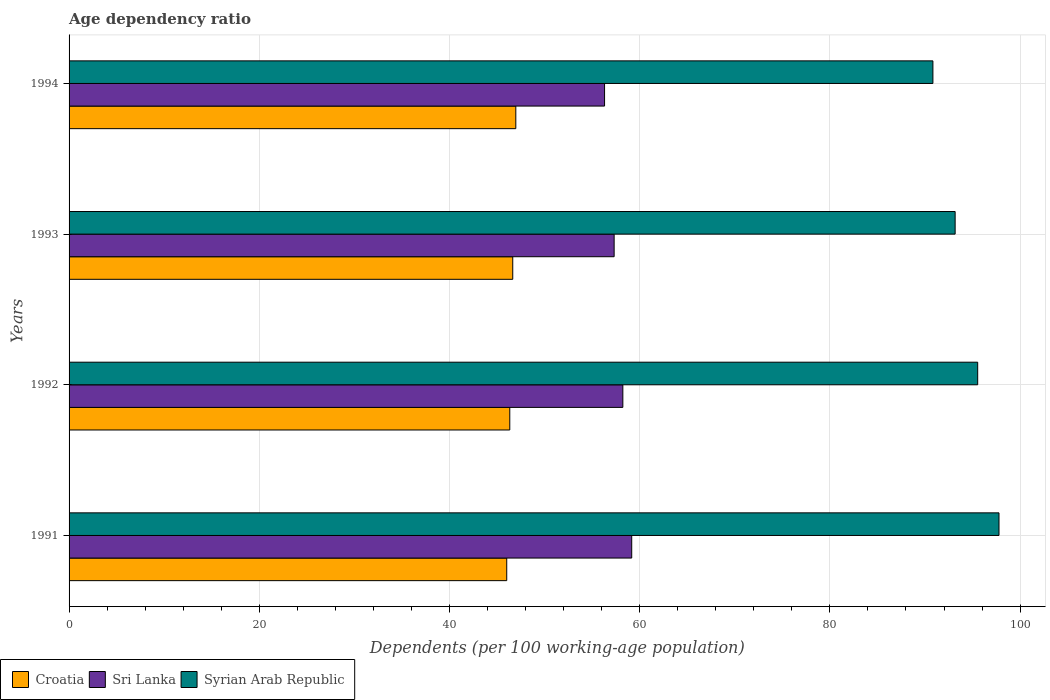How many different coloured bars are there?
Provide a short and direct response. 3. Are the number of bars per tick equal to the number of legend labels?
Provide a short and direct response. Yes. How many bars are there on the 3rd tick from the top?
Provide a short and direct response. 3. How many bars are there on the 4th tick from the bottom?
Ensure brevity in your answer.  3. In how many cases, is the number of bars for a given year not equal to the number of legend labels?
Offer a very short reply. 0. What is the age dependency ratio in in Sri Lanka in 1994?
Your answer should be very brief. 56.31. Across all years, what is the maximum age dependency ratio in in Syrian Arab Republic?
Your response must be concise. 97.78. Across all years, what is the minimum age dependency ratio in in Syrian Arab Republic?
Offer a terse response. 90.83. In which year was the age dependency ratio in in Syrian Arab Republic maximum?
Your answer should be compact. 1991. In which year was the age dependency ratio in in Croatia minimum?
Offer a very short reply. 1991. What is the total age dependency ratio in in Sri Lanka in the graph?
Ensure brevity in your answer.  231.01. What is the difference between the age dependency ratio in in Croatia in 1991 and that in 1993?
Your response must be concise. -0.63. What is the difference between the age dependency ratio in in Sri Lanka in 1993 and the age dependency ratio in in Croatia in 1992?
Keep it short and to the point. 10.97. What is the average age dependency ratio in in Sri Lanka per year?
Offer a very short reply. 57.75. In the year 1991, what is the difference between the age dependency ratio in in Croatia and age dependency ratio in in Sri Lanka?
Provide a short and direct response. -13.14. What is the ratio of the age dependency ratio in in Sri Lanka in 1991 to that in 1994?
Make the answer very short. 1.05. Is the difference between the age dependency ratio in in Croatia in 1991 and 1994 greater than the difference between the age dependency ratio in in Sri Lanka in 1991 and 1994?
Offer a very short reply. No. What is the difference between the highest and the second highest age dependency ratio in in Croatia?
Provide a succinct answer. 0.32. What is the difference between the highest and the lowest age dependency ratio in in Croatia?
Make the answer very short. 0.95. What does the 3rd bar from the top in 1992 represents?
Provide a succinct answer. Croatia. What does the 2nd bar from the bottom in 1992 represents?
Make the answer very short. Sri Lanka. Is it the case that in every year, the sum of the age dependency ratio in in Sri Lanka and age dependency ratio in in Syrian Arab Republic is greater than the age dependency ratio in in Croatia?
Make the answer very short. Yes. Are all the bars in the graph horizontal?
Offer a very short reply. Yes. How many years are there in the graph?
Your response must be concise. 4. What is the difference between two consecutive major ticks on the X-axis?
Make the answer very short. 20. Are the values on the major ticks of X-axis written in scientific E-notation?
Provide a succinct answer. No. Does the graph contain grids?
Your response must be concise. Yes. Where does the legend appear in the graph?
Your answer should be compact. Bottom left. What is the title of the graph?
Keep it short and to the point. Age dependency ratio. Does "Gambia, The" appear as one of the legend labels in the graph?
Make the answer very short. No. What is the label or title of the X-axis?
Offer a very short reply. Dependents (per 100 working-age population). What is the label or title of the Y-axis?
Provide a short and direct response. Years. What is the Dependents (per 100 working-age population) of Croatia in 1991?
Your response must be concise. 46.02. What is the Dependents (per 100 working-age population) in Sri Lanka in 1991?
Provide a short and direct response. 59.16. What is the Dependents (per 100 working-age population) of Syrian Arab Republic in 1991?
Your response must be concise. 97.78. What is the Dependents (per 100 working-age population) in Croatia in 1992?
Give a very brief answer. 46.34. What is the Dependents (per 100 working-age population) in Sri Lanka in 1992?
Your answer should be very brief. 58.23. What is the Dependents (per 100 working-age population) of Syrian Arab Republic in 1992?
Make the answer very short. 95.54. What is the Dependents (per 100 working-age population) of Croatia in 1993?
Your response must be concise. 46.65. What is the Dependents (per 100 working-age population) of Sri Lanka in 1993?
Ensure brevity in your answer.  57.31. What is the Dependents (per 100 working-age population) in Syrian Arab Republic in 1993?
Your answer should be compact. 93.17. What is the Dependents (per 100 working-age population) in Croatia in 1994?
Give a very brief answer. 46.97. What is the Dependents (per 100 working-age population) of Sri Lanka in 1994?
Keep it short and to the point. 56.31. What is the Dependents (per 100 working-age population) in Syrian Arab Republic in 1994?
Offer a terse response. 90.83. Across all years, what is the maximum Dependents (per 100 working-age population) in Croatia?
Provide a short and direct response. 46.97. Across all years, what is the maximum Dependents (per 100 working-age population) of Sri Lanka?
Provide a short and direct response. 59.16. Across all years, what is the maximum Dependents (per 100 working-age population) of Syrian Arab Republic?
Make the answer very short. 97.78. Across all years, what is the minimum Dependents (per 100 working-age population) of Croatia?
Keep it short and to the point. 46.02. Across all years, what is the minimum Dependents (per 100 working-age population) in Sri Lanka?
Keep it short and to the point. 56.31. Across all years, what is the minimum Dependents (per 100 working-age population) in Syrian Arab Republic?
Your answer should be compact. 90.83. What is the total Dependents (per 100 working-age population) of Croatia in the graph?
Your answer should be compact. 185.99. What is the total Dependents (per 100 working-age population) in Sri Lanka in the graph?
Keep it short and to the point. 231.01. What is the total Dependents (per 100 working-age population) in Syrian Arab Republic in the graph?
Ensure brevity in your answer.  377.32. What is the difference between the Dependents (per 100 working-age population) of Croatia in 1991 and that in 1992?
Make the answer very short. -0.32. What is the difference between the Dependents (per 100 working-age population) in Sri Lanka in 1991 and that in 1992?
Provide a succinct answer. 0.93. What is the difference between the Dependents (per 100 working-age population) in Syrian Arab Republic in 1991 and that in 1992?
Ensure brevity in your answer.  2.24. What is the difference between the Dependents (per 100 working-age population) of Croatia in 1991 and that in 1993?
Give a very brief answer. -0.63. What is the difference between the Dependents (per 100 working-age population) of Sri Lanka in 1991 and that in 1993?
Give a very brief answer. 1.85. What is the difference between the Dependents (per 100 working-age population) of Syrian Arab Republic in 1991 and that in 1993?
Provide a succinct answer. 4.61. What is the difference between the Dependents (per 100 working-age population) of Croatia in 1991 and that in 1994?
Offer a terse response. -0.95. What is the difference between the Dependents (per 100 working-age population) of Sri Lanka in 1991 and that in 1994?
Give a very brief answer. 2.85. What is the difference between the Dependents (per 100 working-age population) in Syrian Arab Republic in 1991 and that in 1994?
Your response must be concise. 6.95. What is the difference between the Dependents (per 100 working-age population) of Croatia in 1992 and that in 1993?
Give a very brief answer. -0.31. What is the difference between the Dependents (per 100 working-age population) of Sri Lanka in 1992 and that in 1993?
Your answer should be very brief. 0.92. What is the difference between the Dependents (per 100 working-age population) in Syrian Arab Republic in 1992 and that in 1993?
Offer a terse response. 2.37. What is the difference between the Dependents (per 100 working-age population) in Croatia in 1992 and that in 1994?
Your response must be concise. -0.63. What is the difference between the Dependents (per 100 working-age population) in Sri Lanka in 1992 and that in 1994?
Offer a very short reply. 1.92. What is the difference between the Dependents (per 100 working-age population) in Syrian Arab Republic in 1992 and that in 1994?
Provide a short and direct response. 4.71. What is the difference between the Dependents (per 100 working-age population) in Croatia in 1993 and that in 1994?
Ensure brevity in your answer.  -0.32. What is the difference between the Dependents (per 100 working-age population) in Sri Lanka in 1993 and that in 1994?
Make the answer very short. 1.01. What is the difference between the Dependents (per 100 working-age population) in Syrian Arab Republic in 1993 and that in 1994?
Offer a very short reply. 2.34. What is the difference between the Dependents (per 100 working-age population) of Croatia in 1991 and the Dependents (per 100 working-age population) of Sri Lanka in 1992?
Provide a short and direct response. -12.21. What is the difference between the Dependents (per 100 working-age population) of Croatia in 1991 and the Dependents (per 100 working-age population) of Syrian Arab Republic in 1992?
Make the answer very short. -49.52. What is the difference between the Dependents (per 100 working-age population) of Sri Lanka in 1991 and the Dependents (per 100 working-age population) of Syrian Arab Republic in 1992?
Ensure brevity in your answer.  -36.38. What is the difference between the Dependents (per 100 working-age population) in Croatia in 1991 and the Dependents (per 100 working-age population) in Sri Lanka in 1993?
Offer a very short reply. -11.29. What is the difference between the Dependents (per 100 working-age population) in Croatia in 1991 and the Dependents (per 100 working-age population) in Syrian Arab Republic in 1993?
Your response must be concise. -47.15. What is the difference between the Dependents (per 100 working-age population) in Sri Lanka in 1991 and the Dependents (per 100 working-age population) in Syrian Arab Republic in 1993?
Give a very brief answer. -34.01. What is the difference between the Dependents (per 100 working-age population) of Croatia in 1991 and the Dependents (per 100 working-age population) of Sri Lanka in 1994?
Your response must be concise. -10.29. What is the difference between the Dependents (per 100 working-age population) in Croatia in 1991 and the Dependents (per 100 working-age population) in Syrian Arab Republic in 1994?
Offer a terse response. -44.81. What is the difference between the Dependents (per 100 working-age population) in Sri Lanka in 1991 and the Dependents (per 100 working-age population) in Syrian Arab Republic in 1994?
Make the answer very short. -31.67. What is the difference between the Dependents (per 100 working-age population) in Croatia in 1992 and the Dependents (per 100 working-age population) in Sri Lanka in 1993?
Make the answer very short. -10.97. What is the difference between the Dependents (per 100 working-age population) of Croatia in 1992 and the Dependents (per 100 working-age population) of Syrian Arab Republic in 1993?
Offer a terse response. -46.83. What is the difference between the Dependents (per 100 working-age population) in Sri Lanka in 1992 and the Dependents (per 100 working-age population) in Syrian Arab Republic in 1993?
Offer a very short reply. -34.94. What is the difference between the Dependents (per 100 working-age population) in Croatia in 1992 and the Dependents (per 100 working-age population) in Sri Lanka in 1994?
Provide a succinct answer. -9.97. What is the difference between the Dependents (per 100 working-age population) of Croatia in 1992 and the Dependents (per 100 working-age population) of Syrian Arab Republic in 1994?
Keep it short and to the point. -44.49. What is the difference between the Dependents (per 100 working-age population) in Sri Lanka in 1992 and the Dependents (per 100 working-age population) in Syrian Arab Republic in 1994?
Keep it short and to the point. -32.6. What is the difference between the Dependents (per 100 working-age population) of Croatia in 1993 and the Dependents (per 100 working-age population) of Sri Lanka in 1994?
Keep it short and to the point. -9.65. What is the difference between the Dependents (per 100 working-age population) of Croatia in 1993 and the Dependents (per 100 working-age population) of Syrian Arab Republic in 1994?
Provide a short and direct response. -44.18. What is the difference between the Dependents (per 100 working-age population) in Sri Lanka in 1993 and the Dependents (per 100 working-age population) in Syrian Arab Republic in 1994?
Make the answer very short. -33.52. What is the average Dependents (per 100 working-age population) of Croatia per year?
Your answer should be very brief. 46.5. What is the average Dependents (per 100 working-age population) of Sri Lanka per year?
Provide a succinct answer. 57.75. What is the average Dependents (per 100 working-age population) of Syrian Arab Republic per year?
Your response must be concise. 94.33. In the year 1991, what is the difference between the Dependents (per 100 working-age population) in Croatia and Dependents (per 100 working-age population) in Sri Lanka?
Your answer should be compact. -13.14. In the year 1991, what is the difference between the Dependents (per 100 working-age population) of Croatia and Dependents (per 100 working-age population) of Syrian Arab Republic?
Offer a very short reply. -51.76. In the year 1991, what is the difference between the Dependents (per 100 working-age population) in Sri Lanka and Dependents (per 100 working-age population) in Syrian Arab Republic?
Your answer should be very brief. -38.62. In the year 1992, what is the difference between the Dependents (per 100 working-age population) of Croatia and Dependents (per 100 working-age population) of Sri Lanka?
Offer a very short reply. -11.89. In the year 1992, what is the difference between the Dependents (per 100 working-age population) of Croatia and Dependents (per 100 working-age population) of Syrian Arab Republic?
Offer a very short reply. -49.2. In the year 1992, what is the difference between the Dependents (per 100 working-age population) in Sri Lanka and Dependents (per 100 working-age population) in Syrian Arab Republic?
Your answer should be very brief. -37.31. In the year 1993, what is the difference between the Dependents (per 100 working-age population) of Croatia and Dependents (per 100 working-age population) of Sri Lanka?
Provide a short and direct response. -10.66. In the year 1993, what is the difference between the Dependents (per 100 working-age population) in Croatia and Dependents (per 100 working-age population) in Syrian Arab Republic?
Give a very brief answer. -46.52. In the year 1993, what is the difference between the Dependents (per 100 working-age population) of Sri Lanka and Dependents (per 100 working-age population) of Syrian Arab Republic?
Give a very brief answer. -35.86. In the year 1994, what is the difference between the Dependents (per 100 working-age population) of Croatia and Dependents (per 100 working-age population) of Sri Lanka?
Your response must be concise. -9.33. In the year 1994, what is the difference between the Dependents (per 100 working-age population) in Croatia and Dependents (per 100 working-age population) in Syrian Arab Republic?
Your response must be concise. -43.86. In the year 1994, what is the difference between the Dependents (per 100 working-age population) of Sri Lanka and Dependents (per 100 working-age population) of Syrian Arab Republic?
Ensure brevity in your answer.  -34.52. What is the ratio of the Dependents (per 100 working-age population) in Croatia in 1991 to that in 1992?
Provide a succinct answer. 0.99. What is the ratio of the Dependents (per 100 working-age population) in Sri Lanka in 1991 to that in 1992?
Your answer should be very brief. 1.02. What is the ratio of the Dependents (per 100 working-age population) of Syrian Arab Republic in 1991 to that in 1992?
Your response must be concise. 1.02. What is the ratio of the Dependents (per 100 working-age population) of Croatia in 1991 to that in 1993?
Offer a very short reply. 0.99. What is the ratio of the Dependents (per 100 working-age population) of Sri Lanka in 1991 to that in 1993?
Offer a terse response. 1.03. What is the ratio of the Dependents (per 100 working-age population) of Syrian Arab Republic in 1991 to that in 1993?
Your response must be concise. 1.05. What is the ratio of the Dependents (per 100 working-age population) in Croatia in 1991 to that in 1994?
Your answer should be compact. 0.98. What is the ratio of the Dependents (per 100 working-age population) of Sri Lanka in 1991 to that in 1994?
Offer a terse response. 1.05. What is the ratio of the Dependents (per 100 working-age population) in Syrian Arab Republic in 1991 to that in 1994?
Ensure brevity in your answer.  1.08. What is the ratio of the Dependents (per 100 working-age population) in Sri Lanka in 1992 to that in 1993?
Provide a short and direct response. 1.02. What is the ratio of the Dependents (per 100 working-age population) in Syrian Arab Republic in 1992 to that in 1993?
Your answer should be compact. 1.03. What is the ratio of the Dependents (per 100 working-age population) of Croatia in 1992 to that in 1994?
Provide a short and direct response. 0.99. What is the ratio of the Dependents (per 100 working-age population) of Sri Lanka in 1992 to that in 1994?
Provide a short and direct response. 1.03. What is the ratio of the Dependents (per 100 working-age population) in Syrian Arab Republic in 1992 to that in 1994?
Offer a terse response. 1.05. What is the ratio of the Dependents (per 100 working-age population) of Sri Lanka in 1993 to that in 1994?
Make the answer very short. 1.02. What is the ratio of the Dependents (per 100 working-age population) of Syrian Arab Republic in 1993 to that in 1994?
Keep it short and to the point. 1.03. What is the difference between the highest and the second highest Dependents (per 100 working-age population) in Croatia?
Give a very brief answer. 0.32. What is the difference between the highest and the second highest Dependents (per 100 working-age population) in Sri Lanka?
Your answer should be very brief. 0.93. What is the difference between the highest and the second highest Dependents (per 100 working-age population) of Syrian Arab Republic?
Your answer should be very brief. 2.24. What is the difference between the highest and the lowest Dependents (per 100 working-age population) of Croatia?
Keep it short and to the point. 0.95. What is the difference between the highest and the lowest Dependents (per 100 working-age population) of Sri Lanka?
Keep it short and to the point. 2.85. What is the difference between the highest and the lowest Dependents (per 100 working-age population) in Syrian Arab Republic?
Offer a very short reply. 6.95. 